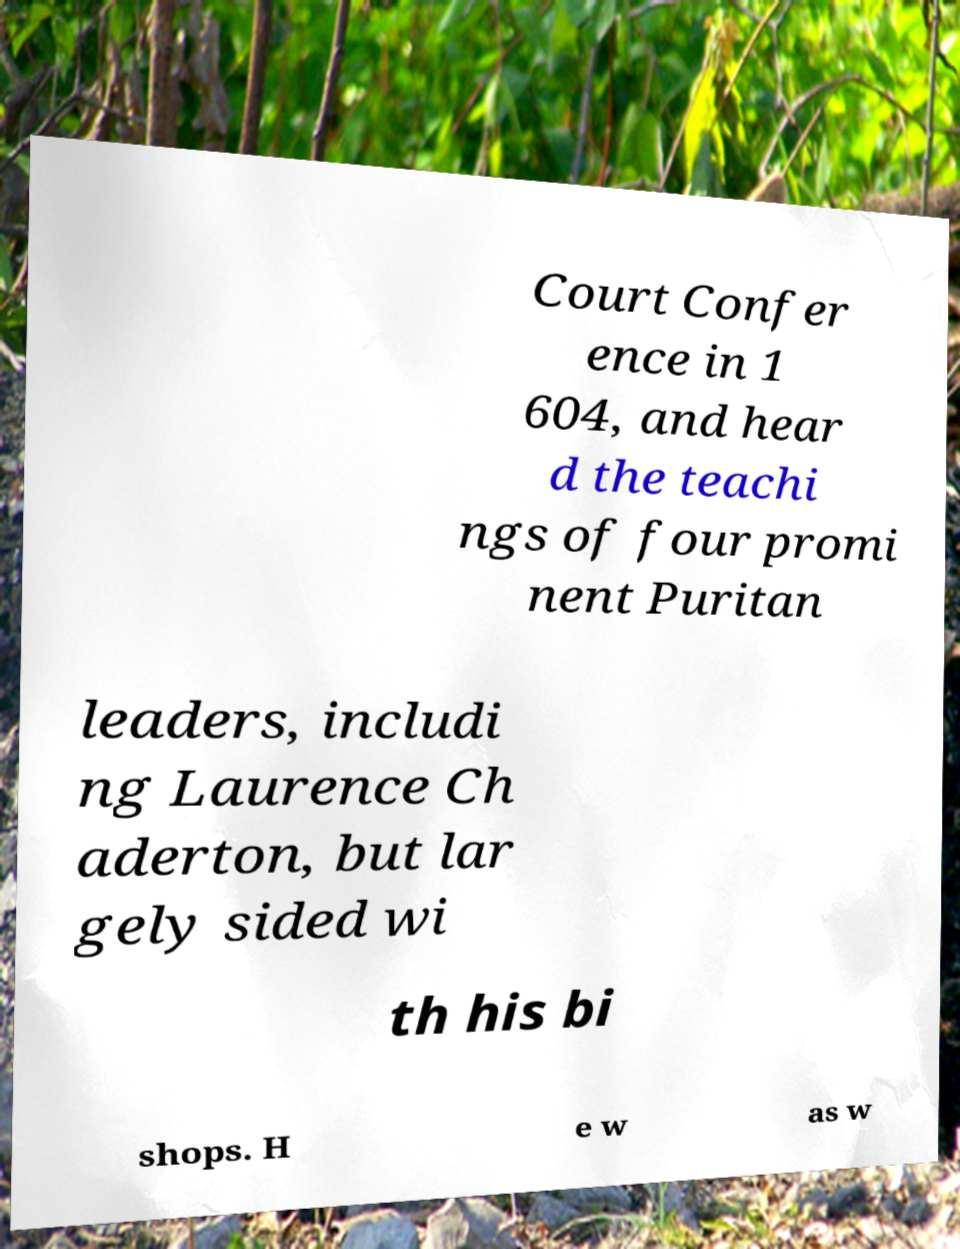Can you accurately transcribe the text from the provided image for me? Court Confer ence in 1 604, and hear d the teachi ngs of four promi nent Puritan leaders, includi ng Laurence Ch aderton, but lar gely sided wi th his bi shops. H e w as w 